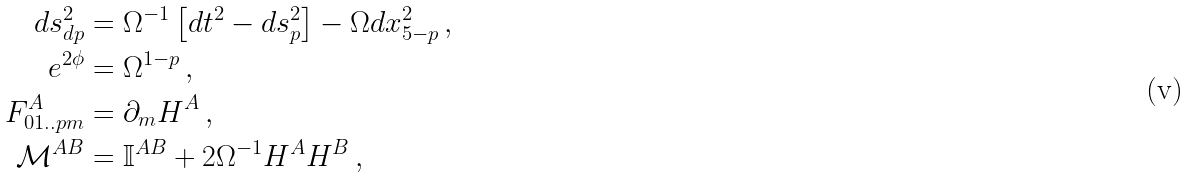Convert formula to latex. <formula><loc_0><loc_0><loc_500><loc_500>d s ^ { 2 } _ { d p } & = { \Omega } ^ { - 1 } \left [ d t ^ { 2 } - d s _ { p } ^ { 2 } \right ] - { \Omega } d x _ { 5 - p } ^ { 2 } \, , \\ e ^ { 2 \phi } & = { \Omega } ^ { 1 - p } \, , \\ F ^ { A } _ { 0 1 . . p m } & = \partial _ { m } H ^ { A } \, , \\ \mathcal { M } ^ { A B } & = \mathbb { I } ^ { A B } + 2 { \Omega } ^ { - 1 } H ^ { A } H ^ { B } \, ,</formula> 